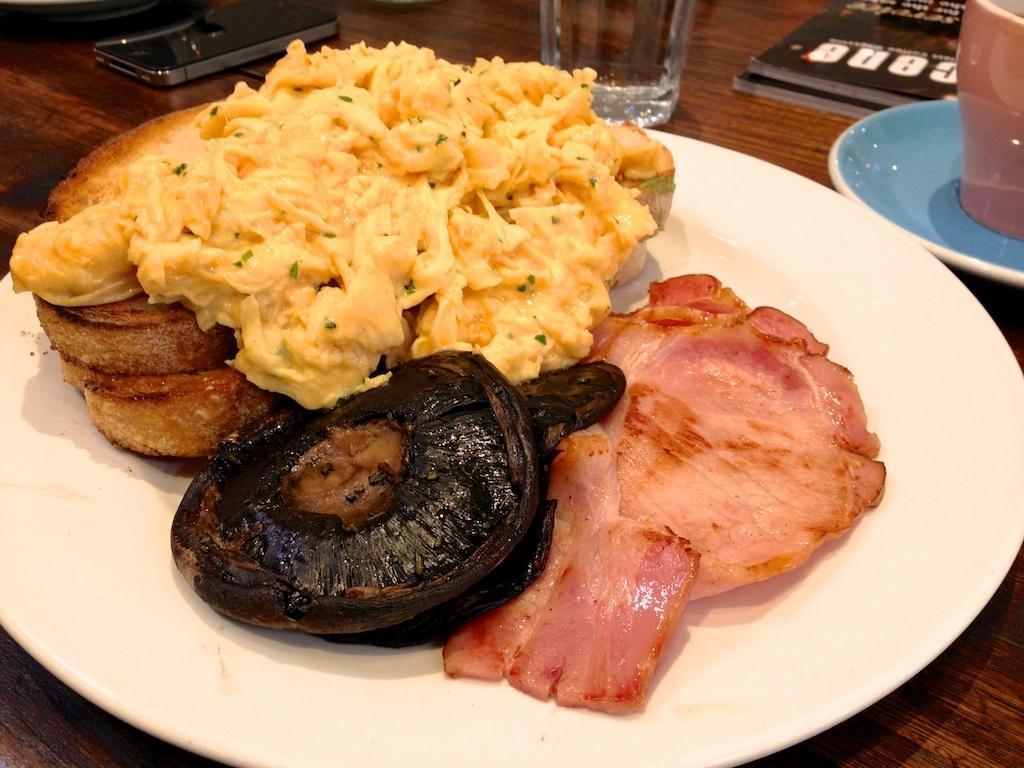Could you give a brief overview of what you see in this image? In this picture there is a food item in the white color plate, which is placed on the wooden table top. Beside there is a water glass and blue color teacup. 